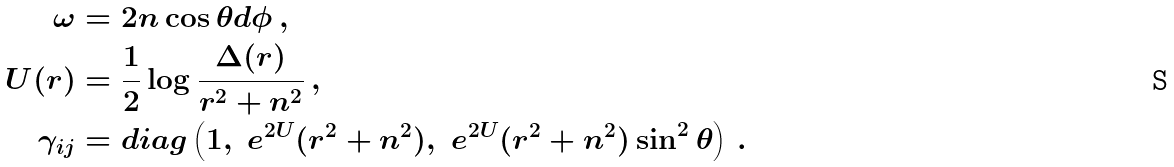<formula> <loc_0><loc_0><loc_500><loc_500>\omega & = 2 n \cos \theta d \phi \, , \\ U ( r ) & = \frac { 1 } { 2 } \log \frac { \Delta ( r ) } { r ^ { 2 } + n ^ { 2 } } \, , \\ \gamma _ { i j } & = d i a g \left ( 1 , \ e ^ { 2 U } ( r ^ { 2 } + n ^ { 2 } ) , \ e ^ { 2 U } ( r ^ { 2 } + n ^ { 2 } ) \sin ^ { 2 } \theta \right ) \, .</formula> 